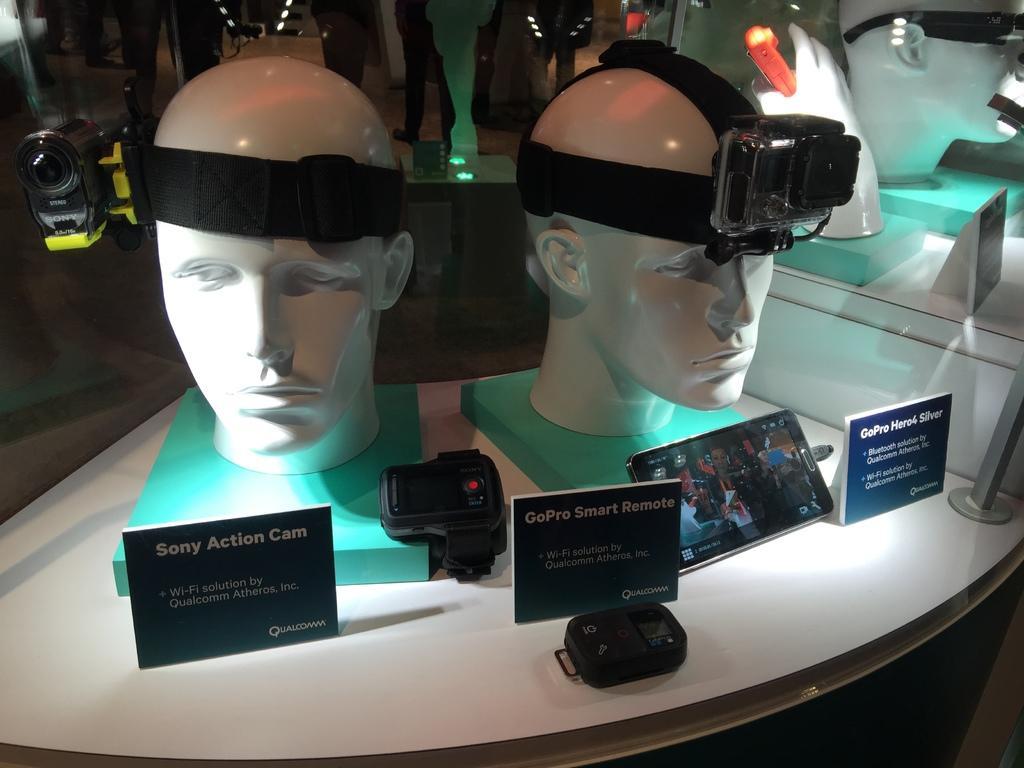Could you give a brief overview of what you see in this image? In this picture we can see there are mannequin heads, hand, cameras, boards and other things on an object. Behind the mannequin heads there is a glass. 